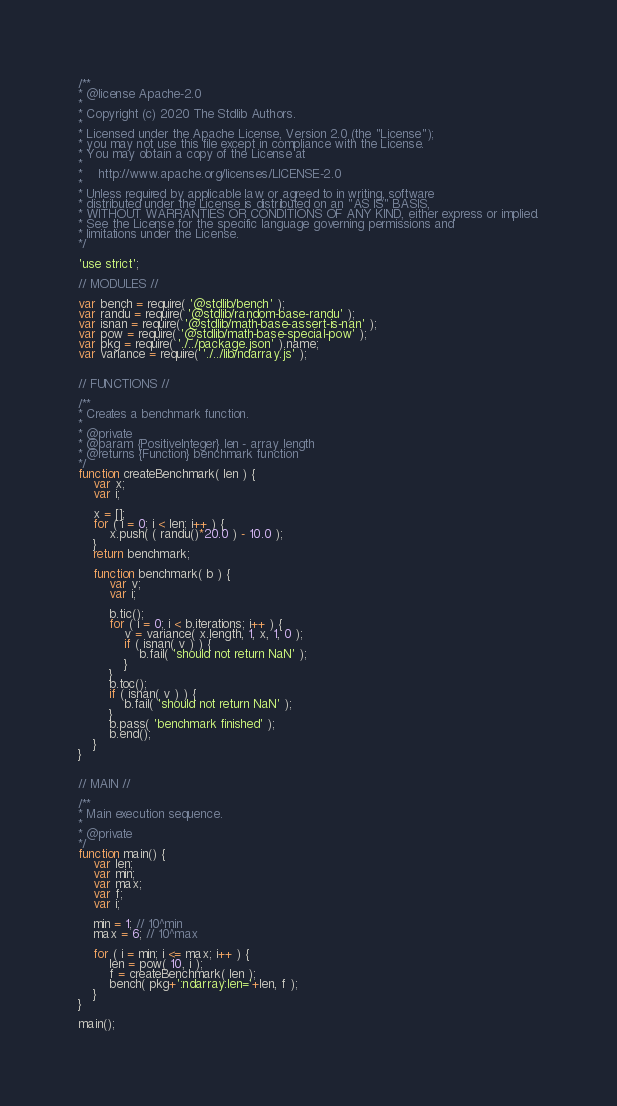Convert code to text. <code><loc_0><loc_0><loc_500><loc_500><_JavaScript_>/**
* @license Apache-2.0
*
* Copyright (c) 2020 The Stdlib Authors.
*
* Licensed under the Apache License, Version 2.0 (the "License");
* you may not use this file except in compliance with the License.
* You may obtain a copy of the License at
*
*    http://www.apache.org/licenses/LICENSE-2.0
*
* Unless required by applicable law or agreed to in writing, software
* distributed under the License is distributed on an "AS IS" BASIS,
* WITHOUT WARRANTIES OR CONDITIONS OF ANY KIND, either express or implied.
* See the License for the specific language governing permissions and
* limitations under the License.
*/

'use strict';

// MODULES //

var bench = require( '@stdlib/bench' );
var randu = require( '@stdlib/random-base-randu' );
var isnan = require( '@stdlib/math-base-assert-is-nan' );
var pow = require( '@stdlib/math-base-special-pow' );
var pkg = require( './../package.json' ).name;
var variance = require( './../lib/ndarray.js' );


// FUNCTIONS //

/**
* Creates a benchmark function.
*
* @private
* @param {PositiveInteger} len - array length
* @returns {Function} benchmark function
*/
function createBenchmark( len ) {
	var x;
	var i;

	x = [];
	for ( i = 0; i < len; i++ ) {
		x.push( ( randu()*20.0 ) - 10.0 );
	}
	return benchmark;

	function benchmark( b ) {
		var v;
		var i;

		b.tic();
		for ( i = 0; i < b.iterations; i++ ) {
			v = variance( x.length, 1, x, 1, 0 );
			if ( isnan( v ) ) {
				b.fail( 'should not return NaN' );
			}
		}
		b.toc();
		if ( isnan( v ) ) {
			b.fail( 'should not return NaN' );
		}
		b.pass( 'benchmark finished' );
		b.end();
	}
}


// MAIN //

/**
* Main execution sequence.
*
* @private
*/
function main() {
	var len;
	var min;
	var max;
	var f;
	var i;

	min = 1; // 10^min
	max = 6; // 10^max

	for ( i = min; i <= max; i++ ) {
		len = pow( 10, i );
		f = createBenchmark( len );
		bench( pkg+':ndarray:len='+len, f );
	}
}

main();
</code> 